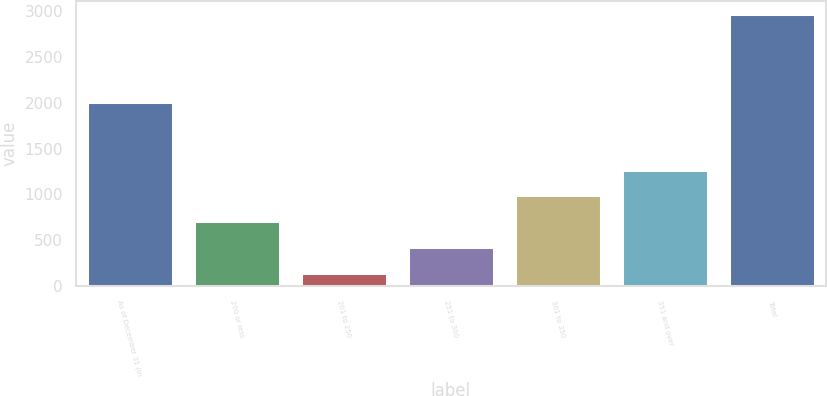<chart> <loc_0><loc_0><loc_500><loc_500><bar_chart><fcel>As of December 31 (in<fcel>200 or less<fcel>201 to 250<fcel>251 to 300<fcel>301 to 350<fcel>351 and over<fcel>Total<nl><fcel>2005<fcel>707.46<fcel>143.8<fcel>425.63<fcel>989.29<fcel>1271.12<fcel>2962.1<nl></chart> 